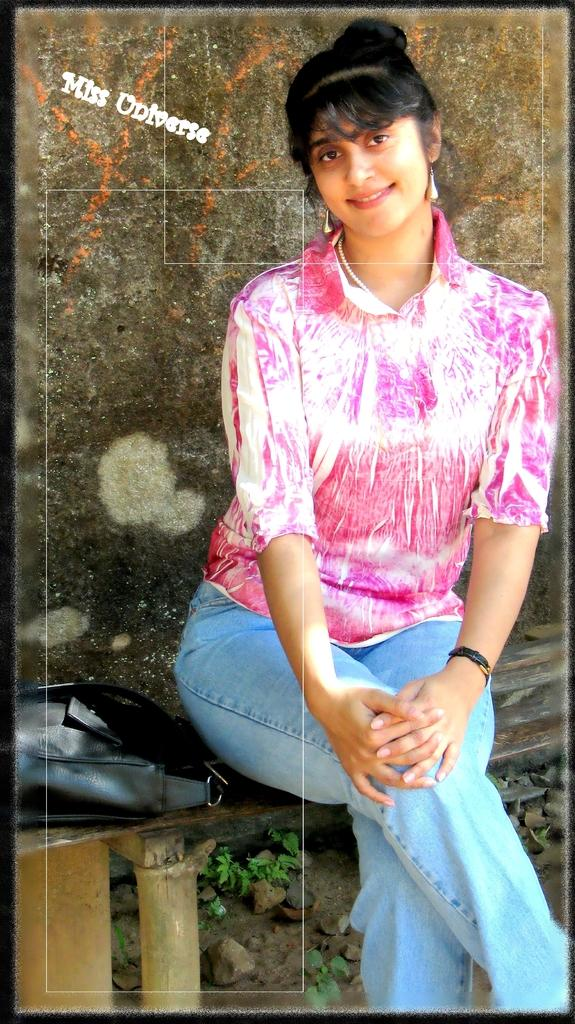What is the woman in the image doing? The woman is sitting on a bench in the image. What object can be seen near the woman? There is a bag in the image. What can be seen in the background of the image? There is a wall in the background of the image. What type of surface is visible at the bottom of the image? Stones and plants are present at the bottom of the image. What type of curve can be seen in the image? There is no curve present in the image. Can you see a kitty playing with a ball in the image? There is no kitty or ball present in the image. 